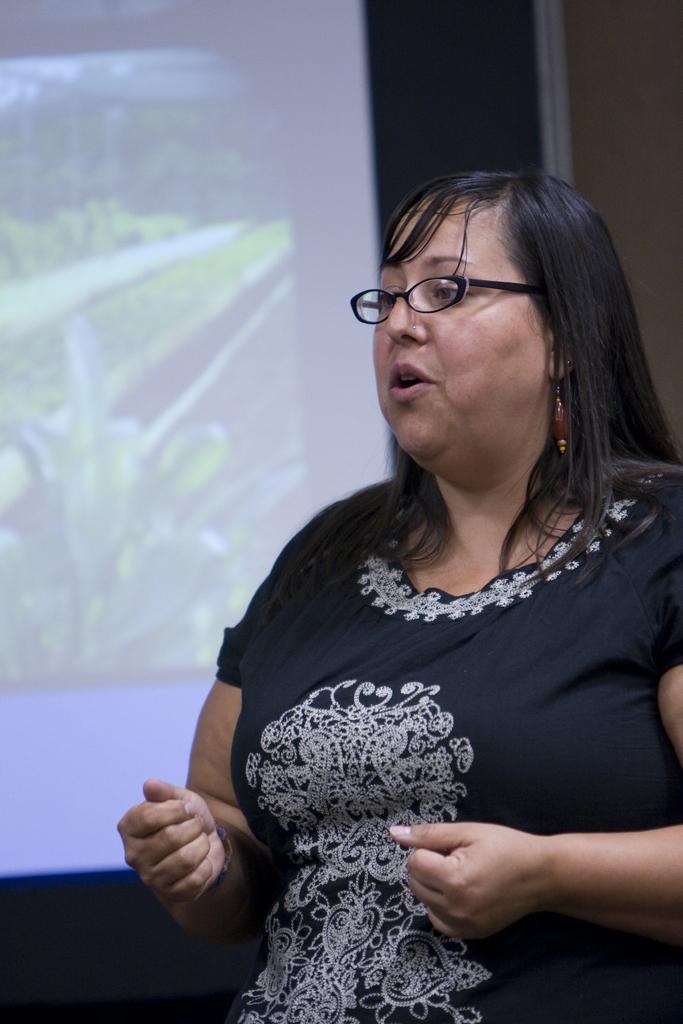Who is the main subject in the image? There is a woman in the image. What is the woman doing in the image? The woman appears to be speaking. What is the woman wearing in the image? The woman is wearing a black top. What can be seen in the background of the image? There is a screen visible in the background of the image. What type of glue is the woman using to attach the band in the image? There is no glue or band present in the image; the woman is simply speaking. 